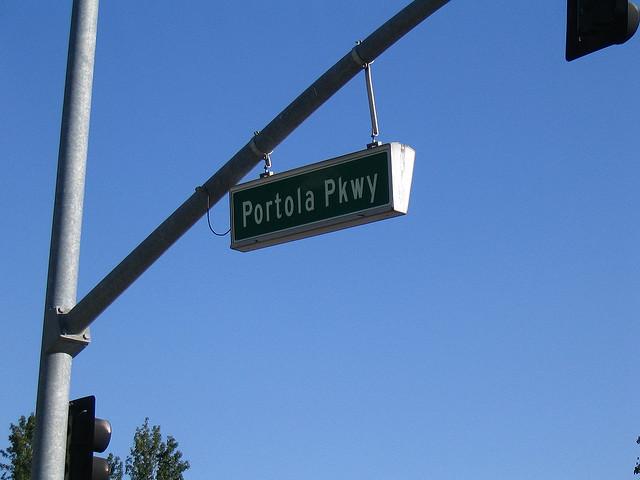Is there a security camera?
Quick response, please. No. What color is the sky?
Give a very brief answer. Blue. What color is the street sign?
Answer briefly. Green. What is the name of this road?
Write a very short answer. Portola pkwy. 